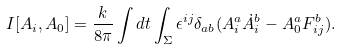Convert formula to latex. <formula><loc_0><loc_0><loc_500><loc_500>I [ A _ { i } , A _ { 0 } ] = \frac { k } { 8 \pi } \int d t \int _ { \Sigma } \epsilon ^ { i j } \delta _ { a b } ( A ^ { a } _ { i } \dot { A } _ { i } ^ { b } - A ^ { a } _ { 0 } F ^ { b } _ { i j } ) .</formula> 